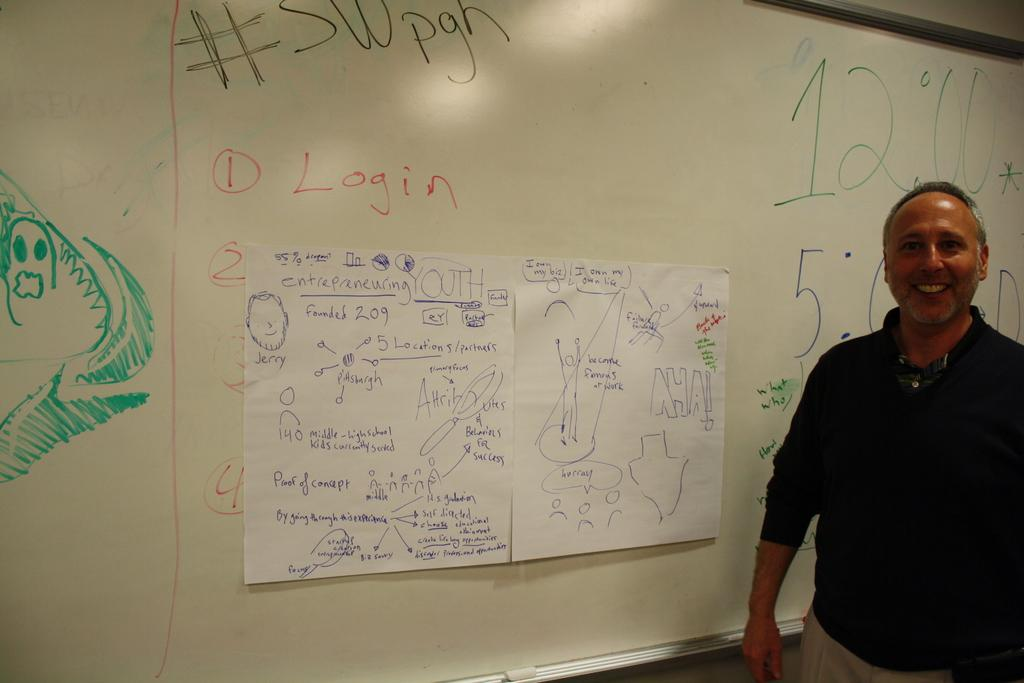<image>
Present a compact description of the photo's key features. A man stands next to a whiteboard with step 1 listed as "login". 